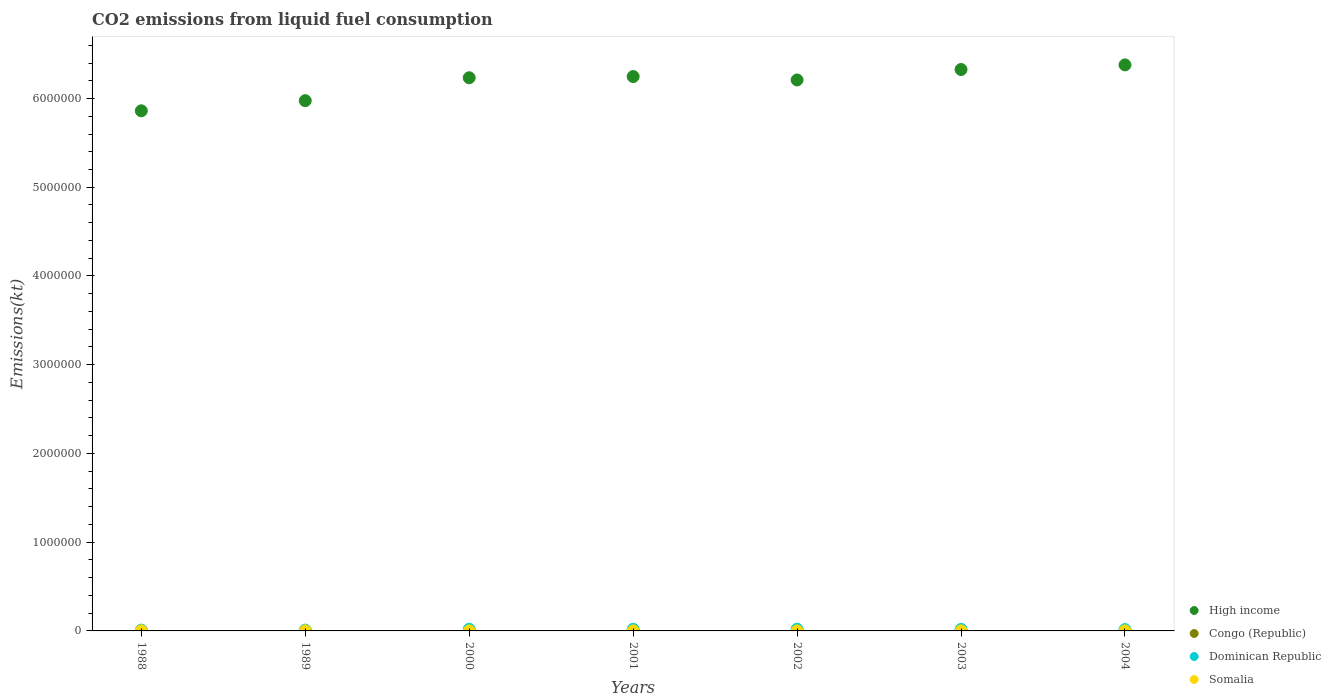What is the amount of CO2 emitted in Dominican Republic in 2000?
Provide a succinct answer. 1.83e+04. Across all years, what is the maximum amount of CO2 emitted in Dominican Republic?
Your answer should be very brief. 1.92e+04. Across all years, what is the minimum amount of CO2 emitted in Dominican Republic?
Your answer should be very brief. 8833.8. In which year was the amount of CO2 emitted in Congo (Republic) maximum?
Provide a short and direct response. 1988. In which year was the amount of CO2 emitted in Somalia minimum?
Provide a short and direct response. 2001. What is the total amount of CO2 emitted in Dominican Republic in the graph?
Make the answer very short. 1.04e+05. What is the difference between the amount of CO2 emitted in Dominican Republic in 2000 and that in 2002?
Give a very brief answer. -902.08. What is the difference between the amount of CO2 emitted in Dominican Republic in 2003 and the amount of CO2 emitted in Somalia in 2000?
Offer a very short reply. 1.62e+04. What is the average amount of CO2 emitted in Somalia per year?
Make the answer very short. 672.63. In the year 2002, what is the difference between the amount of CO2 emitted in Dominican Republic and amount of CO2 emitted in Somalia?
Offer a very short reply. 1.86e+04. What is the ratio of the amount of CO2 emitted in Somalia in 2001 to that in 2004?
Make the answer very short. 0.85. What is the difference between the highest and the second highest amount of CO2 emitted in Somalia?
Provide a succinct answer. 51.34. What is the difference between the highest and the lowest amount of CO2 emitted in Congo (Republic)?
Offer a very short reply. 733.4. Is the sum of the amount of CO2 emitted in High income in 2002 and 2003 greater than the maximum amount of CO2 emitted in Dominican Republic across all years?
Provide a short and direct response. Yes. Is it the case that in every year, the sum of the amount of CO2 emitted in Dominican Republic and amount of CO2 emitted in High income  is greater than the sum of amount of CO2 emitted in Congo (Republic) and amount of CO2 emitted in Somalia?
Ensure brevity in your answer.  Yes. Is the amount of CO2 emitted in Dominican Republic strictly greater than the amount of CO2 emitted in High income over the years?
Keep it short and to the point. No. What is the difference between two consecutive major ticks on the Y-axis?
Give a very brief answer. 1.00e+06. Does the graph contain any zero values?
Keep it short and to the point. No. Does the graph contain grids?
Make the answer very short. No. How many legend labels are there?
Provide a succinct answer. 4. What is the title of the graph?
Your response must be concise. CO2 emissions from liquid fuel consumption. Does "Croatia" appear as one of the legend labels in the graph?
Provide a short and direct response. No. What is the label or title of the Y-axis?
Your answer should be very brief. Emissions(kt). What is the Emissions(kt) of High income in 1988?
Give a very brief answer. 5.86e+06. What is the Emissions(kt) in Congo (Republic) in 1988?
Provide a succinct answer. 1290.78. What is the Emissions(kt) of Dominican Republic in 1988?
Offer a very short reply. 8833.8. What is the Emissions(kt) in Somalia in 1988?
Your answer should be very brief. 982.76. What is the Emissions(kt) in High income in 1989?
Offer a very short reply. 5.98e+06. What is the Emissions(kt) in Congo (Republic) in 1989?
Provide a short and direct response. 1272.45. What is the Emissions(kt) of Dominican Republic in 1989?
Provide a succinct answer. 8870.47. What is the Emissions(kt) of Somalia in 1989?
Provide a short and direct response. 931.42. What is the Emissions(kt) in High income in 2000?
Your response must be concise. 6.23e+06. What is the Emissions(kt) in Congo (Republic) in 2000?
Your answer should be compact. 557.38. What is the Emissions(kt) of Dominican Republic in 2000?
Give a very brief answer. 1.83e+04. What is the Emissions(kt) in Somalia in 2000?
Ensure brevity in your answer.  517.05. What is the Emissions(kt) of High income in 2001?
Offer a terse response. 6.25e+06. What is the Emissions(kt) in Congo (Republic) in 2001?
Ensure brevity in your answer.  766.4. What is the Emissions(kt) in Dominican Republic in 2001?
Provide a succinct answer. 1.79e+04. What is the Emissions(kt) of Somalia in 2001?
Your answer should be very brief. 502.38. What is the Emissions(kt) in High income in 2002?
Ensure brevity in your answer.  6.21e+06. What is the Emissions(kt) of Congo (Republic) in 2002?
Your response must be concise. 575.72. What is the Emissions(kt) in Dominican Republic in 2002?
Make the answer very short. 1.92e+04. What is the Emissions(kt) in Somalia in 2002?
Offer a very short reply. 586.72. What is the Emissions(kt) of High income in 2003?
Provide a short and direct response. 6.33e+06. What is the Emissions(kt) of Congo (Republic) in 2003?
Keep it short and to the point. 883.75. What is the Emissions(kt) in Dominican Republic in 2003?
Offer a very short reply. 1.67e+04. What is the Emissions(kt) in Somalia in 2003?
Ensure brevity in your answer.  594.05. What is the Emissions(kt) in High income in 2004?
Your response must be concise. 6.38e+06. What is the Emissions(kt) in Congo (Republic) in 2004?
Provide a succinct answer. 913.08. What is the Emissions(kt) of Dominican Republic in 2004?
Your answer should be compact. 1.47e+04. What is the Emissions(kt) in Somalia in 2004?
Keep it short and to the point. 594.05. Across all years, what is the maximum Emissions(kt) in High income?
Give a very brief answer. 6.38e+06. Across all years, what is the maximum Emissions(kt) in Congo (Republic)?
Your response must be concise. 1290.78. Across all years, what is the maximum Emissions(kt) of Dominican Republic?
Provide a short and direct response. 1.92e+04. Across all years, what is the maximum Emissions(kt) of Somalia?
Provide a short and direct response. 982.76. Across all years, what is the minimum Emissions(kt) of High income?
Your answer should be compact. 5.86e+06. Across all years, what is the minimum Emissions(kt) in Congo (Republic)?
Your answer should be compact. 557.38. Across all years, what is the minimum Emissions(kt) of Dominican Republic?
Keep it short and to the point. 8833.8. Across all years, what is the minimum Emissions(kt) of Somalia?
Ensure brevity in your answer.  502.38. What is the total Emissions(kt) of High income in the graph?
Your response must be concise. 4.32e+07. What is the total Emissions(kt) of Congo (Republic) in the graph?
Give a very brief answer. 6259.57. What is the total Emissions(kt) of Dominican Republic in the graph?
Offer a very short reply. 1.04e+05. What is the total Emissions(kt) of Somalia in the graph?
Give a very brief answer. 4708.43. What is the difference between the Emissions(kt) in High income in 1988 and that in 1989?
Offer a terse response. -1.14e+05. What is the difference between the Emissions(kt) in Congo (Republic) in 1988 and that in 1989?
Make the answer very short. 18.34. What is the difference between the Emissions(kt) of Dominican Republic in 1988 and that in 1989?
Provide a succinct answer. -36.67. What is the difference between the Emissions(kt) of Somalia in 1988 and that in 1989?
Your answer should be compact. 51.34. What is the difference between the Emissions(kt) of High income in 1988 and that in 2000?
Make the answer very short. -3.73e+05. What is the difference between the Emissions(kt) in Congo (Republic) in 1988 and that in 2000?
Your answer should be very brief. 733.4. What is the difference between the Emissions(kt) in Dominican Republic in 1988 and that in 2000?
Offer a very short reply. -9457.19. What is the difference between the Emissions(kt) of Somalia in 1988 and that in 2000?
Provide a short and direct response. 465.71. What is the difference between the Emissions(kt) of High income in 1988 and that in 2001?
Ensure brevity in your answer.  -3.86e+05. What is the difference between the Emissions(kt) in Congo (Republic) in 1988 and that in 2001?
Your answer should be compact. 524.38. What is the difference between the Emissions(kt) in Dominican Republic in 1988 and that in 2001?
Keep it short and to the point. -9075.83. What is the difference between the Emissions(kt) of Somalia in 1988 and that in 2001?
Offer a terse response. 480.38. What is the difference between the Emissions(kt) of High income in 1988 and that in 2002?
Your response must be concise. -3.48e+05. What is the difference between the Emissions(kt) of Congo (Republic) in 1988 and that in 2002?
Keep it short and to the point. 715.07. What is the difference between the Emissions(kt) of Dominican Republic in 1988 and that in 2002?
Provide a succinct answer. -1.04e+04. What is the difference between the Emissions(kt) of Somalia in 1988 and that in 2002?
Make the answer very short. 396.04. What is the difference between the Emissions(kt) of High income in 1988 and that in 2003?
Keep it short and to the point. -4.66e+05. What is the difference between the Emissions(kt) of Congo (Republic) in 1988 and that in 2003?
Your response must be concise. 407.04. What is the difference between the Emissions(kt) of Dominican Republic in 1988 and that in 2003?
Make the answer very short. -7854.71. What is the difference between the Emissions(kt) in Somalia in 1988 and that in 2003?
Provide a succinct answer. 388.7. What is the difference between the Emissions(kt) of High income in 1988 and that in 2004?
Give a very brief answer. -5.18e+05. What is the difference between the Emissions(kt) of Congo (Republic) in 1988 and that in 2004?
Keep it short and to the point. 377.7. What is the difference between the Emissions(kt) in Dominican Republic in 1988 and that in 2004?
Keep it short and to the point. -5852.53. What is the difference between the Emissions(kt) in Somalia in 1988 and that in 2004?
Offer a very short reply. 388.7. What is the difference between the Emissions(kt) in High income in 1989 and that in 2000?
Offer a very short reply. -2.58e+05. What is the difference between the Emissions(kt) in Congo (Republic) in 1989 and that in 2000?
Your answer should be compact. 715.07. What is the difference between the Emissions(kt) of Dominican Republic in 1989 and that in 2000?
Keep it short and to the point. -9420.52. What is the difference between the Emissions(kt) in Somalia in 1989 and that in 2000?
Offer a terse response. 414.37. What is the difference between the Emissions(kt) in High income in 1989 and that in 2001?
Offer a terse response. -2.72e+05. What is the difference between the Emissions(kt) in Congo (Republic) in 1989 and that in 2001?
Your response must be concise. 506.05. What is the difference between the Emissions(kt) in Dominican Republic in 1989 and that in 2001?
Your answer should be compact. -9039.16. What is the difference between the Emissions(kt) of Somalia in 1989 and that in 2001?
Provide a succinct answer. 429.04. What is the difference between the Emissions(kt) in High income in 1989 and that in 2002?
Your answer should be very brief. -2.33e+05. What is the difference between the Emissions(kt) of Congo (Republic) in 1989 and that in 2002?
Make the answer very short. 696.73. What is the difference between the Emissions(kt) in Dominican Republic in 1989 and that in 2002?
Keep it short and to the point. -1.03e+04. What is the difference between the Emissions(kt) of Somalia in 1989 and that in 2002?
Your response must be concise. 344.7. What is the difference between the Emissions(kt) in High income in 1989 and that in 2003?
Your answer should be very brief. -3.51e+05. What is the difference between the Emissions(kt) of Congo (Republic) in 1989 and that in 2003?
Your answer should be compact. 388.7. What is the difference between the Emissions(kt) of Dominican Republic in 1989 and that in 2003?
Keep it short and to the point. -7818.04. What is the difference between the Emissions(kt) of Somalia in 1989 and that in 2003?
Your answer should be very brief. 337.36. What is the difference between the Emissions(kt) of High income in 1989 and that in 2004?
Provide a succinct answer. -4.03e+05. What is the difference between the Emissions(kt) in Congo (Republic) in 1989 and that in 2004?
Make the answer very short. 359.37. What is the difference between the Emissions(kt) of Dominican Republic in 1989 and that in 2004?
Provide a short and direct response. -5815.86. What is the difference between the Emissions(kt) of Somalia in 1989 and that in 2004?
Your answer should be compact. 337.36. What is the difference between the Emissions(kt) of High income in 2000 and that in 2001?
Offer a terse response. -1.36e+04. What is the difference between the Emissions(kt) in Congo (Republic) in 2000 and that in 2001?
Your response must be concise. -209.02. What is the difference between the Emissions(kt) of Dominican Republic in 2000 and that in 2001?
Your response must be concise. 381.37. What is the difference between the Emissions(kt) of Somalia in 2000 and that in 2001?
Ensure brevity in your answer.  14.67. What is the difference between the Emissions(kt) of High income in 2000 and that in 2002?
Your answer should be compact. 2.47e+04. What is the difference between the Emissions(kt) of Congo (Republic) in 2000 and that in 2002?
Provide a succinct answer. -18.34. What is the difference between the Emissions(kt) in Dominican Republic in 2000 and that in 2002?
Provide a succinct answer. -902.08. What is the difference between the Emissions(kt) of Somalia in 2000 and that in 2002?
Provide a short and direct response. -69.67. What is the difference between the Emissions(kt) of High income in 2000 and that in 2003?
Ensure brevity in your answer.  -9.30e+04. What is the difference between the Emissions(kt) in Congo (Republic) in 2000 and that in 2003?
Keep it short and to the point. -326.36. What is the difference between the Emissions(kt) in Dominican Republic in 2000 and that in 2003?
Make the answer very short. 1602.48. What is the difference between the Emissions(kt) of Somalia in 2000 and that in 2003?
Your response must be concise. -77.01. What is the difference between the Emissions(kt) in High income in 2000 and that in 2004?
Offer a very short reply. -1.45e+05. What is the difference between the Emissions(kt) in Congo (Republic) in 2000 and that in 2004?
Keep it short and to the point. -355.7. What is the difference between the Emissions(kt) of Dominican Republic in 2000 and that in 2004?
Provide a short and direct response. 3604.66. What is the difference between the Emissions(kt) in Somalia in 2000 and that in 2004?
Offer a very short reply. -77.01. What is the difference between the Emissions(kt) in High income in 2001 and that in 2002?
Ensure brevity in your answer.  3.84e+04. What is the difference between the Emissions(kt) of Congo (Republic) in 2001 and that in 2002?
Your answer should be very brief. 190.68. What is the difference between the Emissions(kt) of Dominican Republic in 2001 and that in 2002?
Keep it short and to the point. -1283.45. What is the difference between the Emissions(kt) in Somalia in 2001 and that in 2002?
Ensure brevity in your answer.  -84.34. What is the difference between the Emissions(kt) in High income in 2001 and that in 2003?
Keep it short and to the point. -7.94e+04. What is the difference between the Emissions(kt) in Congo (Republic) in 2001 and that in 2003?
Make the answer very short. -117.34. What is the difference between the Emissions(kt) of Dominican Republic in 2001 and that in 2003?
Offer a very short reply. 1221.11. What is the difference between the Emissions(kt) of Somalia in 2001 and that in 2003?
Offer a terse response. -91.67. What is the difference between the Emissions(kt) of High income in 2001 and that in 2004?
Provide a short and direct response. -1.32e+05. What is the difference between the Emissions(kt) in Congo (Republic) in 2001 and that in 2004?
Ensure brevity in your answer.  -146.68. What is the difference between the Emissions(kt) in Dominican Republic in 2001 and that in 2004?
Provide a short and direct response. 3223.29. What is the difference between the Emissions(kt) in Somalia in 2001 and that in 2004?
Offer a terse response. -91.67. What is the difference between the Emissions(kt) of High income in 2002 and that in 2003?
Provide a succinct answer. -1.18e+05. What is the difference between the Emissions(kt) in Congo (Republic) in 2002 and that in 2003?
Ensure brevity in your answer.  -308.03. What is the difference between the Emissions(kt) of Dominican Republic in 2002 and that in 2003?
Ensure brevity in your answer.  2504.56. What is the difference between the Emissions(kt) of Somalia in 2002 and that in 2003?
Offer a terse response. -7.33. What is the difference between the Emissions(kt) of High income in 2002 and that in 2004?
Your response must be concise. -1.70e+05. What is the difference between the Emissions(kt) of Congo (Republic) in 2002 and that in 2004?
Keep it short and to the point. -337.36. What is the difference between the Emissions(kt) in Dominican Republic in 2002 and that in 2004?
Your response must be concise. 4506.74. What is the difference between the Emissions(kt) in Somalia in 2002 and that in 2004?
Give a very brief answer. -7.33. What is the difference between the Emissions(kt) of High income in 2003 and that in 2004?
Keep it short and to the point. -5.21e+04. What is the difference between the Emissions(kt) in Congo (Republic) in 2003 and that in 2004?
Ensure brevity in your answer.  -29.34. What is the difference between the Emissions(kt) in Dominican Republic in 2003 and that in 2004?
Make the answer very short. 2002.18. What is the difference between the Emissions(kt) in Somalia in 2003 and that in 2004?
Provide a short and direct response. 0. What is the difference between the Emissions(kt) of High income in 1988 and the Emissions(kt) of Congo (Republic) in 1989?
Keep it short and to the point. 5.86e+06. What is the difference between the Emissions(kt) in High income in 1988 and the Emissions(kt) in Dominican Republic in 1989?
Keep it short and to the point. 5.85e+06. What is the difference between the Emissions(kt) in High income in 1988 and the Emissions(kt) in Somalia in 1989?
Make the answer very short. 5.86e+06. What is the difference between the Emissions(kt) of Congo (Republic) in 1988 and the Emissions(kt) of Dominican Republic in 1989?
Provide a short and direct response. -7579.69. What is the difference between the Emissions(kt) in Congo (Republic) in 1988 and the Emissions(kt) in Somalia in 1989?
Your answer should be compact. 359.37. What is the difference between the Emissions(kt) in Dominican Republic in 1988 and the Emissions(kt) in Somalia in 1989?
Your answer should be compact. 7902.39. What is the difference between the Emissions(kt) in High income in 1988 and the Emissions(kt) in Congo (Republic) in 2000?
Provide a short and direct response. 5.86e+06. What is the difference between the Emissions(kt) in High income in 1988 and the Emissions(kt) in Dominican Republic in 2000?
Keep it short and to the point. 5.84e+06. What is the difference between the Emissions(kt) in High income in 1988 and the Emissions(kt) in Somalia in 2000?
Make the answer very short. 5.86e+06. What is the difference between the Emissions(kt) of Congo (Republic) in 1988 and the Emissions(kt) of Dominican Republic in 2000?
Offer a terse response. -1.70e+04. What is the difference between the Emissions(kt) of Congo (Republic) in 1988 and the Emissions(kt) of Somalia in 2000?
Ensure brevity in your answer.  773.74. What is the difference between the Emissions(kt) of Dominican Republic in 1988 and the Emissions(kt) of Somalia in 2000?
Your response must be concise. 8316.76. What is the difference between the Emissions(kt) of High income in 1988 and the Emissions(kt) of Congo (Republic) in 2001?
Give a very brief answer. 5.86e+06. What is the difference between the Emissions(kt) in High income in 1988 and the Emissions(kt) in Dominican Republic in 2001?
Your response must be concise. 5.84e+06. What is the difference between the Emissions(kt) of High income in 1988 and the Emissions(kt) of Somalia in 2001?
Keep it short and to the point. 5.86e+06. What is the difference between the Emissions(kt) of Congo (Republic) in 1988 and the Emissions(kt) of Dominican Republic in 2001?
Your response must be concise. -1.66e+04. What is the difference between the Emissions(kt) in Congo (Republic) in 1988 and the Emissions(kt) in Somalia in 2001?
Your answer should be very brief. 788.4. What is the difference between the Emissions(kt) in Dominican Republic in 1988 and the Emissions(kt) in Somalia in 2001?
Offer a very short reply. 8331.42. What is the difference between the Emissions(kt) of High income in 1988 and the Emissions(kt) of Congo (Republic) in 2002?
Offer a very short reply. 5.86e+06. What is the difference between the Emissions(kt) in High income in 1988 and the Emissions(kt) in Dominican Republic in 2002?
Make the answer very short. 5.84e+06. What is the difference between the Emissions(kt) of High income in 1988 and the Emissions(kt) of Somalia in 2002?
Your answer should be compact. 5.86e+06. What is the difference between the Emissions(kt) in Congo (Republic) in 1988 and the Emissions(kt) in Dominican Republic in 2002?
Your answer should be compact. -1.79e+04. What is the difference between the Emissions(kt) in Congo (Republic) in 1988 and the Emissions(kt) in Somalia in 2002?
Give a very brief answer. 704.06. What is the difference between the Emissions(kt) in Dominican Republic in 1988 and the Emissions(kt) in Somalia in 2002?
Your answer should be very brief. 8247.08. What is the difference between the Emissions(kt) of High income in 1988 and the Emissions(kt) of Congo (Republic) in 2003?
Your answer should be compact. 5.86e+06. What is the difference between the Emissions(kt) of High income in 1988 and the Emissions(kt) of Dominican Republic in 2003?
Give a very brief answer. 5.84e+06. What is the difference between the Emissions(kt) of High income in 1988 and the Emissions(kt) of Somalia in 2003?
Give a very brief answer. 5.86e+06. What is the difference between the Emissions(kt) of Congo (Republic) in 1988 and the Emissions(kt) of Dominican Republic in 2003?
Your answer should be very brief. -1.54e+04. What is the difference between the Emissions(kt) in Congo (Republic) in 1988 and the Emissions(kt) in Somalia in 2003?
Make the answer very short. 696.73. What is the difference between the Emissions(kt) in Dominican Republic in 1988 and the Emissions(kt) in Somalia in 2003?
Your answer should be very brief. 8239.75. What is the difference between the Emissions(kt) of High income in 1988 and the Emissions(kt) of Congo (Republic) in 2004?
Give a very brief answer. 5.86e+06. What is the difference between the Emissions(kt) of High income in 1988 and the Emissions(kt) of Dominican Republic in 2004?
Provide a short and direct response. 5.85e+06. What is the difference between the Emissions(kt) in High income in 1988 and the Emissions(kt) in Somalia in 2004?
Provide a succinct answer. 5.86e+06. What is the difference between the Emissions(kt) of Congo (Republic) in 1988 and the Emissions(kt) of Dominican Republic in 2004?
Your response must be concise. -1.34e+04. What is the difference between the Emissions(kt) in Congo (Republic) in 1988 and the Emissions(kt) in Somalia in 2004?
Ensure brevity in your answer.  696.73. What is the difference between the Emissions(kt) of Dominican Republic in 1988 and the Emissions(kt) of Somalia in 2004?
Your response must be concise. 8239.75. What is the difference between the Emissions(kt) of High income in 1989 and the Emissions(kt) of Congo (Republic) in 2000?
Ensure brevity in your answer.  5.98e+06. What is the difference between the Emissions(kt) of High income in 1989 and the Emissions(kt) of Dominican Republic in 2000?
Make the answer very short. 5.96e+06. What is the difference between the Emissions(kt) in High income in 1989 and the Emissions(kt) in Somalia in 2000?
Provide a short and direct response. 5.98e+06. What is the difference between the Emissions(kt) of Congo (Republic) in 1989 and the Emissions(kt) of Dominican Republic in 2000?
Provide a succinct answer. -1.70e+04. What is the difference between the Emissions(kt) of Congo (Republic) in 1989 and the Emissions(kt) of Somalia in 2000?
Give a very brief answer. 755.4. What is the difference between the Emissions(kt) of Dominican Republic in 1989 and the Emissions(kt) of Somalia in 2000?
Your answer should be very brief. 8353.43. What is the difference between the Emissions(kt) of High income in 1989 and the Emissions(kt) of Congo (Republic) in 2001?
Offer a terse response. 5.98e+06. What is the difference between the Emissions(kt) in High income in 1989 and the Emissions(kt) in Dominican Republic in 2001?
Ensure brevity in your answer.  5.96e+06. What is the difference between the Emissions(kt) of High income in 1989 and the Emissions(kt) of Somalia in 2001?
Offer a terse response. 5.98e+06. What is the difference between the Emissions(kt) of Congo (Republic) in 1989 and the Emissions(kt) of Dominican Republic in 2001?
Your answer should be compact. -1.66e+04. What is the difference between the Emissions(kt) in Congo (Republic) in 1989 and the Emissions(kt) in Somalia in 2001?
Offer a very short reply. 770.07. What is the difference between the Emissions(kt) in Dominican Republic in 1989 and the Emissions(kt) in Somalia in 2001?
Provide a succinct answer. 8368.09. What is the difference between the Emissions(kt) of High income in 1989 and the Emissions(kt) of Congo (Republic) in 2002?
Provide a succinct answer. 5.98e+06. What is the difference between the Emissions(kt) in High income in 1989 and the Emissions(kt) in Dominican Republic in 2002?
Give a very brief answer. 5.96e+06. What is the difference between the Emissions(kt) of High income in 1989 and the Emissions(kt) of Somalia in 2002?
Offer a terse response. 5.98e+06. What is the difference between the Emissions(kt) of Congo (Republic) in 1989 and the Emissions(kt) of Dominican Republic in 2002?
Give a very brief answer. -1.79e+04. What is the difference between the Emissions(kt) of Congo (Republic) in 1989 and the Emissions(kt) of Somalia in 2002?
Your answer should be very brief. 685.73. What is the difference between the Emissions(kt) in Dominican Republic in 1989 and the Emissions(kt) in Somalia in 2002?
Give a very brief answer. 8283.75. What is the difference between the Emissions(kt) of High income in 1989 and the Emissions(kt) of Congo (Republic) in 2003?
Keep it short and to the point. 5.97e+06. What is the difference between the Emissions(kt) of High income in 1989 and the Emissions(kt) of Dominican Republic in 2003?
Make the answer very short. 5.96e+06. What is the difference between the Emissions(kt) of High income in 1989 and the Emissions(kt) of Somalia in 2003?
Provide a succinct answer. 5.98e+06. What is the difference between the Emissions(kt) of Congo (Republic) in 1989 and the Emissions(kt) of Dominican Republic in 2003?
Your response must be concise. -1.54e+04. What is the difference between the Emissions(kt) of Congo (Republic) in 1989 and the Emissions(kt) of Somalia in 2003?
Keep it short and to the point. 678.39. What is the difference between the Emissions(kt) in Dominican Republic in 1989 and the Emissions(kt) in Somalia in 2003?
Your response must be concise. 8276.42. What is the difference between the Emissions(kt) of High income in 1989 and the Emissions(kt) of Congo (Republic) in 2004?
Keep it short and to the point. 5.97e+06. What is the difference between the Emissions(kt) of High income in 1989 and the Emissions(kt) of Dominican Republic in 2004?
Your response must be concise. 5.96e+06. What is the difference between the Emissions(kt) in High income in 1989 and the Emissions(kt) in Somalia in 2004?
Your answer should be very brief. 5.98e+06. What is the difference between the Emissions(kt) of Congo (Republic) in 1989 and the Emissions(kt) of Dominican Republic in 2004?
Your answer should be compact. -1.34e+04. What is the difference between the Emissions(kt) of Congo (Republic) in 1989 and the Emissions(kt) of Somalia in 2004?
Your answer should be very brief. 678.39. What is the difference between the Emissions(kt) of Dominican Republic in 1989 and the Emissions(kt) of Somalia in 2004?
Offer a very short reply. 8276.42. What is the difference between the Emissions(kt) in High income in 2000 and the Emissions(kt) in Congo (Republic) in 2001?
Give a very brief answer. 6.23e+06. What is the difference between the Emissions(kt) of High income in 2000 and the Emissions(kt) of Dominican Republic in 2001?
Provide a short and direct response. 6.22e+06. What is the difference between the Emissions(kt) in High income in 2000 and the Emissions(kt) in Somalia in 2001?
Make the answer very short. 6.23e+06. What is the difference between the Emissions(kt) in Congo (Republic) in 2000 and the Emissions(kt) in Dominican Republic in 2001?
Your answer should be very brief. -1.74e+04. What is the difference between the Emissions(kt) of Congo (Republic) in 2000 and the Emissions(kt) of Somalia in 2001?
Provide a short and direct response. 55.01. What is the difference between the Emissions(kt) in Dominican Republic in 2000 and the Emissions(kt) in Somalia in 2001?
Give a very brief answer. 1.78e+04. What is the difference between the Emissions(kt) in High income in 2000 and the Emissions(kt) in Congo (Republic) in 2002?
Offer a terse response. 6.23e+06. What is the difference between the Emissions(kt) in High income in 2000 and the Emissions(kt) in Dominican Republic in 2002?
Offer a terse response. 6.21e+06. What is the difference between the Emissions(kt) of High income in 2000 and the Emissions(kt) of Somalia in 2002?
Provide a short and direct response. 6.23e+06. What is the difference between the Emissions(kt) of Congo (Republic) in 2000 and the Emissions(kt) of Dominican Republic in 2002?
Provide a succinct answer. -1.86e+04. What is the difference between the Emissions(kt) of Congo (Republic) in 2000 and the Emissions(kt) of Somalia in 2002?
Make the answer very short. -29.34. What is the difference between the Emissions(kt) in Dominican Republic in 2000 and the Emissions(kt) in Somalia in 2002?
Your answer should be very brief. 1.77e+04. What is the difference between the Emissions(kt) in High income in 2000 and the Emissions(kt) in Congo (Republic) in 2003?
Offer a terse response. 6.23e+06. What is the difference between the Emissions(kt) in High income in 2000 and the Emissions(kt) in Dominican Republic in 2003?
Offer a terse response. 6.22e+06. What is the difference between the Emissions(kt) in High income in 2000 and the Emissions(kt) in Somalia in 2003?
Your answer should be very brief. 6.23e+06. What is the difference between the Emissions(kt) of Congo (Republic) in 2000 and the Emissions(kt) of Dominican Republic in 2003?
Keep it short and to the point. -1.61e+04. What is the difference between the Emissions(kt) of Congo (Republic) in 2000 and the Emissions(kt) of Somalia in 2003?
Offer a terse response. -36.67. What is the difference between the Emissions(kt) of Dominican Republic in 2000 and the Emissions(kt) of Somalia in 2003?
Keep it short and to the point. 1.77e+04. What is the difference between the Emissions(kt) of High income in 2000 and the Emissions(kt) of Congo (Republic) in 2004?
Your answer should be very brief. 6.23e+06. What is the difference between the Emissions(kt) of High income in 2000 and the Emissions(kt) of Dominican Republic in 2004?
Your response must be concise. 6.22e+06. What is the difference between the Emissions(kt) in High income in 2000 and the Emissions(kt) in Somalia in 2004?
Your answer should be very brief. 6.23e+06. What is the difference between the Emissions(kt) of Congo (Republic) in 2000 and the Emissions(kt) of Dominican Republic in 2004?
Your answer should be very brief. -1.41e+04. What is the difference between the Emissions(kt) in Congo (Republic) in 2000 and the Emissions(kt) in Somalia in 2004?
Your answer should be very brief. -36.67. What is the difference between the Emissions(kt) in Dominican Republic in 2000 and the Emissions(kt) in Somalia in 2004?
Provide a short and direct response. 1.77e+04. What is the difference between the Emissions(kt) of High income in 2001 and the Emissions(kt) of Congo (Republic) in 2002?
Make the answer very short. 6.25e+06. What is the difference between the Emissions(kt) in High income in 2001 and the Emissions(kt) in Dominican Republic in 2002?
Ensure brevity in your answer.  6.23e+06. What is the difference between the Emissions(kt) of High income in 2001 and the Emissions(kt) of Somalia in 2002?
Your answer should be compact. 6.25e+06. What is the difference between the Emissions(kt) in Congo (Republic) in 2001 and the Emissions(kt) in Dominican Republic in 2002?
Provide a succinct answer. -1.84e+04. What is the difference between the Emissions(kt) of Congo (Republic) in 2001 and the Emissions(kt) of Somalia in 2002?
Give a very brief answer. 179.68. What is the difference between the Emissions(kt) of Dominican Republic in 2001 and the Emissions(kt) of Somalia in 2002?
Offer a terse response. 1.73e+04. What is the difference between the Emissions(kt) in High income in 2001 and the Emissions(kt) in Congo (Republic) in 2003?
Make the answer very short. 6.25e+06. What is the difference between the Emissions(kt) in High income in 2001 and the Emissions(kt) in Dominican Republic in 2003?
Your answer should be very brief. 6.23e+06. What is the difference between the Emissions(kt) in High income in 2001 and the Emissions(kt) in Somalia in 2003?
Keep it short and to the point. 6.25e+06. What is the difference between the Emissions(kt) in Congo (Republic) in 2001 and the Emissions(kt) in Dominican Republic in 2003?
Provide a short and direct response. -1.59e+04. What is the difference between the Emissions(kt) in Congo (Republic) in 2001 and the Emissions(kt) in Somalia in 2003?
Your answer should be compact. 172.35. What is the difference between the Emissions(kt) of Dominican Republic in 2001 and the Emissions(kt) of Somalia in 2003?
Keep it short and to the point. 1.73e+04. What is the difference between the Emissions(kt) in High income in 2001 and the Emissions(kt) in Congo (Republic) in 2004?
Offer a very short reply. 6.25e+06. What is the difference between the Emissions(kt) of High income in 2001 and the Emissions(kt) of Dominican Republic in 2004?
Offer a terse response. 6.23e+06. What is the difference between the Emissions(kt) of High income in 2001 and the Emissions(kt) of Somalia in 2004?
Provide a succinct answer. 6.25e+06. What is the difference between the Emissions(kt) in Congo (Republic) in 2001 and the Emissions(kt) in Dominican Republic in 2004?
Keep it short and to the point. -1.39e+04. What is the difference between the Emissions(kt) in Congo (Republic) in 2001 and the Emissions(kt) in Somalia in 2004?
Keep it short and to the point. 172.35. What is the difference between the Emissions(kt) of Dominican Republic in 2001 and the Emissions(kt) of Somalia in 2004?
Provide a short and direct response. 1.73e+04. What is the difference between the Emissions(kt) of High income in 2002 and the Emissions(kt) of Congo (Republic) in 2003?
Keep it short and to the point. 6.21e+06. What is the difference between the Emissions(kt) of High income in 2002 and the Emissions(kt) of Dominican Republic in 2003?
Your answer should be very brief. 6.19e+06. What is the difference between the Emissions(kt) of High income in 2002 and the Emissions(kt) of Somalia in 2003?
Keep it short and to the point. 6.21e+06. What is the difference between the Emissions(kt) of Congo (Republic) in 2002 and the Emissions(kt) of Dominican Republic in 2003?
Offer a very short reply. -1.61e+04. What is the difference between the Emissions(kt) of Congo (Republic) in 2002 and the Emissions(kt) of Somalia in 2003?
Offer a very short reply. -18.34. What is the difference between the Emissions(kt) of Dominican Republic in 2002 and the Emissions(kt) of Somalia in 2003?
Offer a very short reply. 1.86e+04. What is the difference between the Emissions(kt) of High income in 2002 and the Emissions(kt) of Congo (Republic) in 2004?
Offer a terse response. 6.21e+06. What is the difference between the Emissions(kt) of High income in 2002 and the Emissions(kt) of Dominican Republic in 2004?
Provide a succinct answer. 6.19e+06. What is the difference between the Emissions(kt) in High income in 2002 and the Emissions(kt) in Somalia in 2004?
Ensure brevity in your answer.  6.21e+06. What is the difference between the Emissions(kt) in Congo (Republic) in 2002 and the Emissions(kt) in Dominican Republic in 2004?
Provide a succinct answer. -1.41e+04. What is the difference between the Emissions(kt) of Congo (Republic) in 2002 and the Emissions(kt) of Somalia in 2004?
Provide a short and direct response. -18.34. What is the difference between the Emissions(kt) in Dominican Republic in 2002 and the Emissions(kt) in Somalia in 2004?
Keep it short and to the point. 1.86e+04. What is the difference between the Emissions(kt) of High income in 2003 and the Emissions(kt) of Congo (Republic) in 2004?
Your answer should be very brief. 6.33e+06. What is the difference between the Emissions(kt) in High income in 2003 and the Emissions(kt) in Dominican Republic in 2004?
Your answer should be compact. 6.31e+06. What is the difference between the Emissions(kt) in High income in 2003 and the Emissions(kt) in Somalia in 2004?
Your answer should be very brief. 6.33e+06. What is the difference between the Emissions(kt) in Congo (Republic) in 2003 and the Emissions(kt) in Dominican Republic in 2004?
Your response must be concise. -1.38e+04. What is the difference between the Emissions(kt) of Congo (Republic) in 2003 and the Emissions(kt) of Somalia in 2004?
Provide a succinct answer. 289.69. What is the difference between the Emissions(kt) in Dominican Republic in 2003 and the Emissions(kt) in Somalia in 2004?
Your response must be concise. 1.61e+04. What is the average Emissions(kt) of High income per year?
Your answer should be very brief. 6.18e+06. What is the average Emissions(kt) of Congo (Republic) per year?
Provide a succinct answer. 894.22. What is the average Emissions(kt) in Dominican Republic per year?
Keep it short and to the point. 1.49e+04. What is the average Emissions(kt) in Somalia per year?
Your answer should be very brief. 672.63. In the year 1988, what is the difference between the Emissions(kt) in High income and Emissions(kt) in Congo (Republic)?
Provide a succinct answer. 5.86e+06. In the year 1988, what is the difference between the Emissions(kt) in High income and Emissions(kt) in Dominican Republic?
Offer a terse response. 5.85e+06. In the year 1988, what is the difference between the Emissions(kt) of High income and Emissions(kt) of Somalia?
Make the answer very short. 5.86e+06. In the year 1988, what is the difference between the Emissions(kt) of Congo (Republic) and Emissions(kt) of Dominican Republic?
Ensure brevity in your answer.  -7543.02. In the year 1988, what is the difference between the Emissions(kt) in Congo (Republic) and Emissions(kt) in Somalia?
Your response must be concise. 308.03. In the year 1988, what is the difference between the Emissions(kt) in Dominican Republic and Emissions(kt) in Somalia?
Provide a succinct answer. 7851.05. In the year 1989, what is the difference between the Emissions(kt) in High income and Emissions(kt) in Congo (Republic)?
Ensure brevity in your answer.  5.97e+06. In the year 1989, what is the difference between the Emissions(kt) in High income and Emissions(kt) in Dominican Republic?
Your answer should be very brief. 5.97e+06. In the year 1989, what is the difference between the Emissions(kt) in High income and Emissions(kt) in Somalia?
Provide a succinct answer. 5.97e+06. In the year 1989, what is the difference between the Emissions(kt) of Congo (Republic) and Emissions(kt) of Dominican Republic?
Your response must be concise. -7598.02. In the year 1989, what is the difference between the Emissions(kt) in Congo (Republic) and Emissions(kt) in Somalia?
Keep it short and to the point. 341.03. In the year 1989, what is the difference between the Emissions(kt) in Dominican Republic and Emissions(kt) in Somalia?
Provide a short and direct response. 7939.06. In the year 2000, what is the difference between the Emissions(kt) in High income and Emissions(kt) in Congo (Republic)?
Your answer should be very brief. 6.23e+06. In the year 2000, what is the difference between the Emissions(kt) in High income and Emissions(kt) in Dominican Republic?
Make the answer very short. 6.22e+06. In the year 2000, what is the difference between the Emissions(kt) in High income and Emissions(kt) in Somalia?
Provide a short and direct response. 6.23e+06. In the year 2000, what is the difference between the Emissions(kt) in Congo (Republic) and Emissions(kt) in Dominican Republic?
Keep it short and to the point. -1.77e+04. In the year 2000, what is the difference between the Emissions(kt) of Congo (Republic) and Emissions(kt) of Somalia?
Your answer should be compact. 40.34. In the year 2000, what is the difference between the Emissions(kt) in Dominican Republic and Emissions(kt) in Somalia?
Keep it short and to the point. 1.78e+04. In the year 2001, what is the difference between the Emissions(kt) of High income and Emissions(kt) of Congo (Republic)?
Make the answer very short. 6.25e+06. In the year 2001, what is the difference between the Emissions(kt) in High income and Emissions(kt) in Dominican Republic?
Provide a short and direct response. 6.23e+06. In the year 2001, what is the difference between the Emissions(kt) of High income and Emissions(kt) of Somalia?
Offer a terse response. 6.25e+06. In the year 2001, what is the difference between the Emissions(kt) in Congo (Republic) and Emissions(kt) in Dominican Republic?
Provide a short and direct response. -1.71e+04. In the year 2001, what is the difference between the Emissions(kt) of Congo (Republic) and Emissions(kt) of Somalia?
Your response must be concise. 264.02. In the year 2001, what is the difference between the Emissions(kt) in Dominican Republic and Emissions(kt) in Somalia?
Provide a succinct answer. 1.74e+04. In the year 2002, what is the difference between the Emissions(kt) in High income and Emissions(kt) in Congo (Republic)?
Offer a terse response. 6.21e+06. In the year 2002, what is the difference between the Emissions(kt) of High income and Emissions(kt) of Dominican Republic?
Your answer should be compact. 6.19e+06. In the year 2002, what is the difference between the Emissions(kt) of High income and Emissions(kt) of Somalia?
Provide a short and direct response. 6.21e+06. In the year 2002, what is the difference between the Emissions(kt) of Congo (Republic) and Emissions(kt) of Dominican Republic?
Your response must be concise. -1.86e+04. In the year 2002, what is the difference between the Emissions(kt) of Congo (Republic) and Emissions(kt) of Somalia?
Keep it short and to the point. -11. In the year 2002, what is the difference between the Emissions(kt) of Dominican Republic and Emissions(kt) of Somalia?
Offer a very short reply. 1.86e+04. In the year 2003, what is the difference between the Emissions(kt) of High income and Emissions(kt) of Congo (Republic)?
Keep it short and to the point. 6.33e+06. In the year 2003, what is the difference between the Emissions(kt) of High income and Emissions(kt) of Dominican Republic?
Make the answer very short. 6.31e+06. In the year 2003, what is the difference between the Emissions(kt) in High income and Emissions(kt) in Somalia?
Provide a short and direct response. 6.33e+06. In the year 2003, what is the difference between the Emissions(kt) in Congo (Republic) and Emissions(kt) in Dominican Republic?
Your response must be concise. -1.58e+04. In the year 2003, what is the difference between the Emissions(kt) in Congo (Republic) and Emissions(kt) in Somalia?
Your answer should be very brief. 289.69. In the year 2003, what is the difference between the Emissions(kt) of Dominican Republic and Emissions(kt) of Somalia?
Offer a terse response. 1.61e+04. In the year 2004, what is the difference between the Emissions(kt) in High income and Emissions(kt) in Congo (Republic)?
Your answer should be very brief. 6.38e+06. In the year 2004, what is the difference between the Emissions(kt) in High income and Emissions(kt) in Dominican Republic?
Offer a terse response. 6.36e+06. In the year 2004, what is the difference between the Emissions(kt) in High income and Emissions(kt) in Somalia?
Give a very brief answer. 6.38e+06. In the year 2004, what is the difference between the Emissions(kt) of Congo (Republic) and Emissions(kt) of Dominican Republic?
Provide a succinct answer. -1.38e+04. In the year 2004, what is the difference between the Emissions(kt) of Congo (Republic) and Emissions(kt) of Somalia?
Your answer should be compact. 319.03. In the year 2004, what is the difference between the Emissions(kt) of Dominican Republic and Emissions(kt) of Somalia?
Make the answer very short. 1.41e+04. What is the ratio of the Emissions(kt) of High income in 1988 to that in 1989?
Offer a very short reply. 0.98. What is the ratio of the Emissions(kt) of Congo (Republic) in 1988 to that in 1989?
Provide a succinct answer. 1.01. What is the ratio of the Emissions(kt) in Somalia in 1988 to that in 1989?
Your answer should be compact. 1.06. What is the ratio of the Emissions(kt) in High income in 1988 to that in 2000?
Ensure brevity in your answer.  0.94. What is the ratio of the Emissions(kt) in Congo (Republic) in 1988 to that in 2000?
Your answer should be compact. 2.32. What is the ratio of the Emissions(kt) in Dominican Republic in 1988 to that in 2000?
Provide a short and direct response. 0.48. What is the ratio of the Emissions(kt) in Somalia in 1988 to that in 2000?
Your answer should be very brief. 1.9. What is the ratio of the Emissions(kt) of High income in 1988 to that in 2001?
Keep it short and to the point. 0.94. What is the ratio of the Emissions(kt) of Congo (Republic) in 1988 to that in 2001?
Make the answer very short. 1.68. What is the ratio of the Emissions(kt) of Dominican Republic in 1988 to that in 2001?
Provide a succinct answer. 0.49. What is the ratio of the Emissions(kt) in Somalia in 1988 to that in 2001?
Your response must be concise. 1.96. What is the ratio of the Emissions(kt) in High income in 1988 to that in 2002?
Give a very brief answer. 0.94. What is the ratio of the Emissions(kt) of Congo (Republic) in 1988 to that in 2002?
Ensure brevity in your answer.  2.24. What is the ratio of the Emissions(kt) of Dominican Republic in 1988 to that in 2002?
Give a very brief answer. 0.46. What is the ratio of the Emissions(kt) of Somalia in 1988 to that in 2002?
Offer a very short reply. 1.68. What is the ratio of the Emissions(kt) of High income in 1988 to that in 2003?
Provide a short and direct response. 0.93. What is the ratio of the Emissions(kt) in Congo (Republic) in 1988 to that in 2003?
Your answer should be very brief. 1.46. What is the ratio of the Emissions(kt) in Dominican Republic in 1988 to that in 2003?
Ensure brevity in your answer.  0.53. What is the ratio of the Emissions(kt) of Somalia in 1988 to that in 2003?
Provide a short and direct response. 1.65. What is the ratio of the Emissions(kt) of High income in 1988 to that in 2004?
Offer a very short reply. 0.92. What is the ratio of the Emissions(kt) of Congo (Republic) in 1988 to that in 2004?
Your response must be concise. 1.41. What is the ratio of the Emissions(kt) of Dominican Republic in 1988 to that in 2004?
Your answer should be very brief. 0.6. What is the ratio of the Emissions(kt) in Somalia in 1988 to that in 2004?
Keep it short and to the point. 1.65. What is the ratio of the Emissions(kt) of High income in 1989 to that in 2000?
Keep it short and to the point. 0.96. What is the ratio of the Emissions(kt) in Congo (Republic) in 1989 to that in 2000?
Provide a succinct answer. 2.28. What is the ratio of the Emissions(kt) of Dominican Republic in 1989 to that in 2000?
Your answer should be very brief. 0.48. What is the ratio of the Emissions(kt) in Somalia in 1989 to that in 2000?
Offer a very short reply. 1.8. What is the ratio of the Emissions(kt) of High income in 1989 to that in 2001?
Your answer should be compact. 0.96. What is the ratio of the Emissions(kt) in Congo (Republic) in 1989 to that in 2001?
Ensure brevity in your answer.  1.66. What is the ratio of the Emissions(kt) of Dominican Republic in 1989 to that in 2001?
Give a very brief answer. 0.5. What is the ratio of the Emissions(kt) in Somalia in 1989 to that in 2001?
Ensure brevity in your answer.  1.85. What is the ratio of the Emissions(kt) of High income in 1989 to that in 2002?
Provide a short and direct response. 0.96. What is the ratio of the Emissions(kt) of Congo (Republic) in 1989 to that in 2002?
Provide a succinct answer. 2.21. What is the ratio of the Emissions(kt) of Dominican Republic in 1989 to that in 2002?
Ensure brevity in your answer.  0.46. What is the ratio of the Emissions(kt) in Somalia in 1989 to that in 2002?
Offer a very short reply. 1.59. What is the ratio of the Emissions(kt) in High income in 1989 to that in 2003?
Your answer should be very brief. 0.94. What is the ratio of the Emissions(kt) in Congo (Republic) in 1989 to that in 2003?
Give a very brief answer. 1.44. What is the ratio of the Emissions(kt) of Dominican Republic in 1989 to that in 2003?
Give a very brief answer. 0.53. What is the ratio of the Emissions(kt) of Somalia in 1989 to that in 2003?
Ensure brevity in your answer.  1.57. What is the ratio of the Emissions(kt) in High income in 1989 to that in 2004?
Give a very brief answer. 0.94. What is the ratio of the Emissions(kt) in Congo (Republic) in 1989 to that in 2004?
Keep it short and to the point. 1.39. What is the ratio of the Emissions(kt) in Dominican Republic in 1989 to that in 2004?
Your answer should be compact. 0.6. What is the ratio of the Emissions(kt) in Somalia in 1989 to that in 2004?
Make the answer very short. 1.57. What is the ratio of the Emissions(kt) of High income in 2000 to that in 2001?
Your answer should be compact. 1. What is the ratio of the Emissions(kt) of Congo (Republic) in 2000 to that in 2001?
Offer a very short reply. 0.73. What is the ratio of the Emissions(kt) in Dominican Republic in 2000 to that in 2001?
Provide a succinct answer. 1.02. What is the ratio of the Emissions(kt) in Somalia in 2000 to that in 2001?
Provide a succinct answer. 1.03. What is the ratio of the Emissions(kt) of Congo (Republic) in 2000 to that in 2002?
Your answer should be very brief. 0.97. What is the ratio of the Emissions(kt) in Dominican Republic in 2000 to that in 2002?
Your response must be concise. 0.95. What is the ratio of the Emissions(kt) in Somalia in 2000 to that in 2002?
Your response must be concise. 0.88. What is the ratio of the Emissions(kt) in High income in 2000 to that in 2003?
Offer a terse response. 0.99. What is the ratio of the Emissions(kt) of Congo (Republic) in 2000 to that in 2003?
Offer a terse response. 0.63. What is the ratio of the Emissions(kt) of Dominican Republic in 2000 to that in 2003?
Offer a terse response. 1.1. What is the ratio of the Emissions(kt) in Somalia in 2000 to that in 2003?
Keep it short and to the point. 0.87. What is the ratio of the Emissions(kt) in High income in 2000 to that in 2004?
Provide a succinct answer. 0.98. What is the ratio of the Emissions(kt) in Congo (Republic) in 2000 to that in 2004?
Provide a short and direct response. 0.61. What is the ratio of the Emissions(kt) of Dominican Republic in 2000 to that in 2004?
Provide a short and direct response. 1.25. What is the ratio of the Emissions(kt) of Somalia in 2000 to that in 2004?
Provide a succinct answer. 0.87. What is the ratio of the Emissions(kt) of Congo (Republic) in 2001 to that in 2002?
Your response must be concise. 1.33. What is the ratio of the Emissions(kt) of Dominican Republic in 2001 to that in 2002?
Keep it short and to the point. 0.93. What is the ratio of the Emissions(kt) in Somalia in 2001 to that in 2002?
Provide a short and direct response. 0.86. What is the ratio of the Emissions(kt) of High income in 2001 to that in 2003?
Make the answer very short. 0.99. What is the ratio of the Emissions(kt) of Congo (Republic) in 2001 to that in 2003?
Provide a succinct answer. 0.87. What is the ratio of the Emissions(kt) of Dominican Republic in 2001 to that in 2003?
Give a very brief answer. 1.07. What is the ratio of the Emissions(kt) in Somalia in 2001 to that in 2003?
Provide a succinct answer. 0.85. What is the ratio of the Emissions(kt) in High income in 2001 to that in 2004?
Offer a very short reply. 0.98. What is the ratio of the Emissions(kt) of Congo (Republic) in 2001 to that in 2004?
Your answer should be compact. 0.84. What is the ratio of the Emissions(kt) of Dominican Republic in 2001 to that in 2004?
Your response must be concise. 1.22. What is the ratio of the Emissions(kt) in Somalia in 2001 to that in 2004?
Your answer should be very brief. 0.85. What is the ratio of the Emissions(kt) in High income in 2002 to that in 2003?
Keep it short and to the point. 0.98. What is the ratio of the Emissions(kt) in Congo (Republic) in 2002 to that in 2003?
Keep it short and to the point. 0.65. What is the ratio of the Emissions(kt) of Dominican Republic in 2002 to that in 2003?
Provide a short and direct response. 1.15. What is the ratio of the Emissions(kt) in Somalia in 2002 to that in 2003?
Your response must be concise. 0.99. What is the ratio of the Emissions(kt) in High income in 2002 to that in 2004?
Your answer should be compact. 0.97. What is the ratio of the Emissions(kt) in Congo (Republic) in 2002 to that in 2004?
Provide a succinct answer. 0.63. What is the ratio of the Emissions(kt) in Dominican Republic in 2002 to that in 2004?
Give a very brief answer. 1.31. What is the ratio of the Emissions(kt) of Somalia in 2002 to that in 2004?
Provide a short and direct response. 0.99. What is the ratio of the Emissions(kt) in Congo (Republic) in 2003 to that in 2004?
Provide a short and direct response. 0.97. What is the ratio of the Emissions(kt) of Dominican Republic in 2003 to that in 2004?
Ensure brevity in your answer.  1.14. What is the difference between the highest and the second highest Emissions(kt) of High income?
Give a very brief answer. 5.21e+04. What is the difference between the highest and the second highest Emissions(kt) of Congo (Republic)?
Make the answer very short. 18.34. What is the difference between the highest and the second highest Emissions(kt) in Dominican Republic?
Offer a terse response. 902.08. What is the difference between the highest and the second highest Emissions(kt) in Somalia?
Provide a succinct answer. 51.34. What is the difference between the highest and the lowest Emissions(kt) of High income?
Your response must be concise. 5.18e+05. What is the difference between the highest and the lowest Emissions(kt) of Congo (Republic)?
Keep it short and to the point. 733.4. What is the difference between the highest and the lowest Emissions(kt) in Dominican Republic?
Offer a very short reply. 1.04e+04. What is the difference between the highest and the lowest Emissions(kt) in Somalia?
Your answer should be compact. 480.38. 